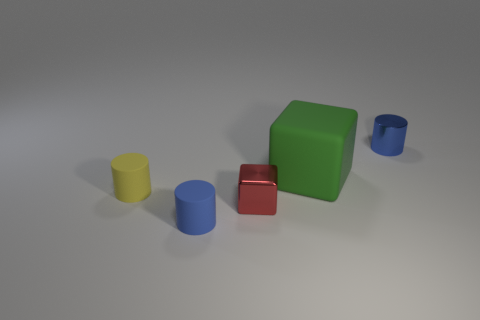What number of objects are tiny cylinders that are left of the tiny blue metal cylinder or large green things?
Provide a short and direct response. 3. Is the shape of the big thing the same as the blue matte object?
Offer a very short reply. No. How many other things are there of the same size as the metallic cube?
Your answer should be very brief. 3. The shiny cylinder is what color?
Keep it short and to the point. Blue. What number of tiny objects are metal things or cubes?
Your answer should be very brief. 2. Does the block to the left of the green matte thing have the same size as the blue metal cylinder on the right side of the small yellow object?
Give a very brief answer. Yes. There is another blue object that is the same shape as the tiny blue shiny thing; what size is it?
Provide a succinct answer. Small. Is the number of small matte cylinders to the right of the yellow cylinder greater than the number of big matte cubes behind the big matte thing?
Ensure brevity in your answer.  Yes. There is a object that is both left of the shiny cylinder and on the right side of the small cube; what is its material?
Ensure brevity in your answer.  Rubber. The big rubber object that is the same shape as the red metallic object is what color?
Offer a very short reply. Green. 